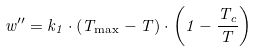<formula> <loc_0><loc_0><loc_500><loc_500>w ^ { \prime \prime } = k _ { 1 } \cdot ( T _ { \max } - T ) \cdot \left ( 1 - \frac { T _ { c } } { T } \right )</formula> 